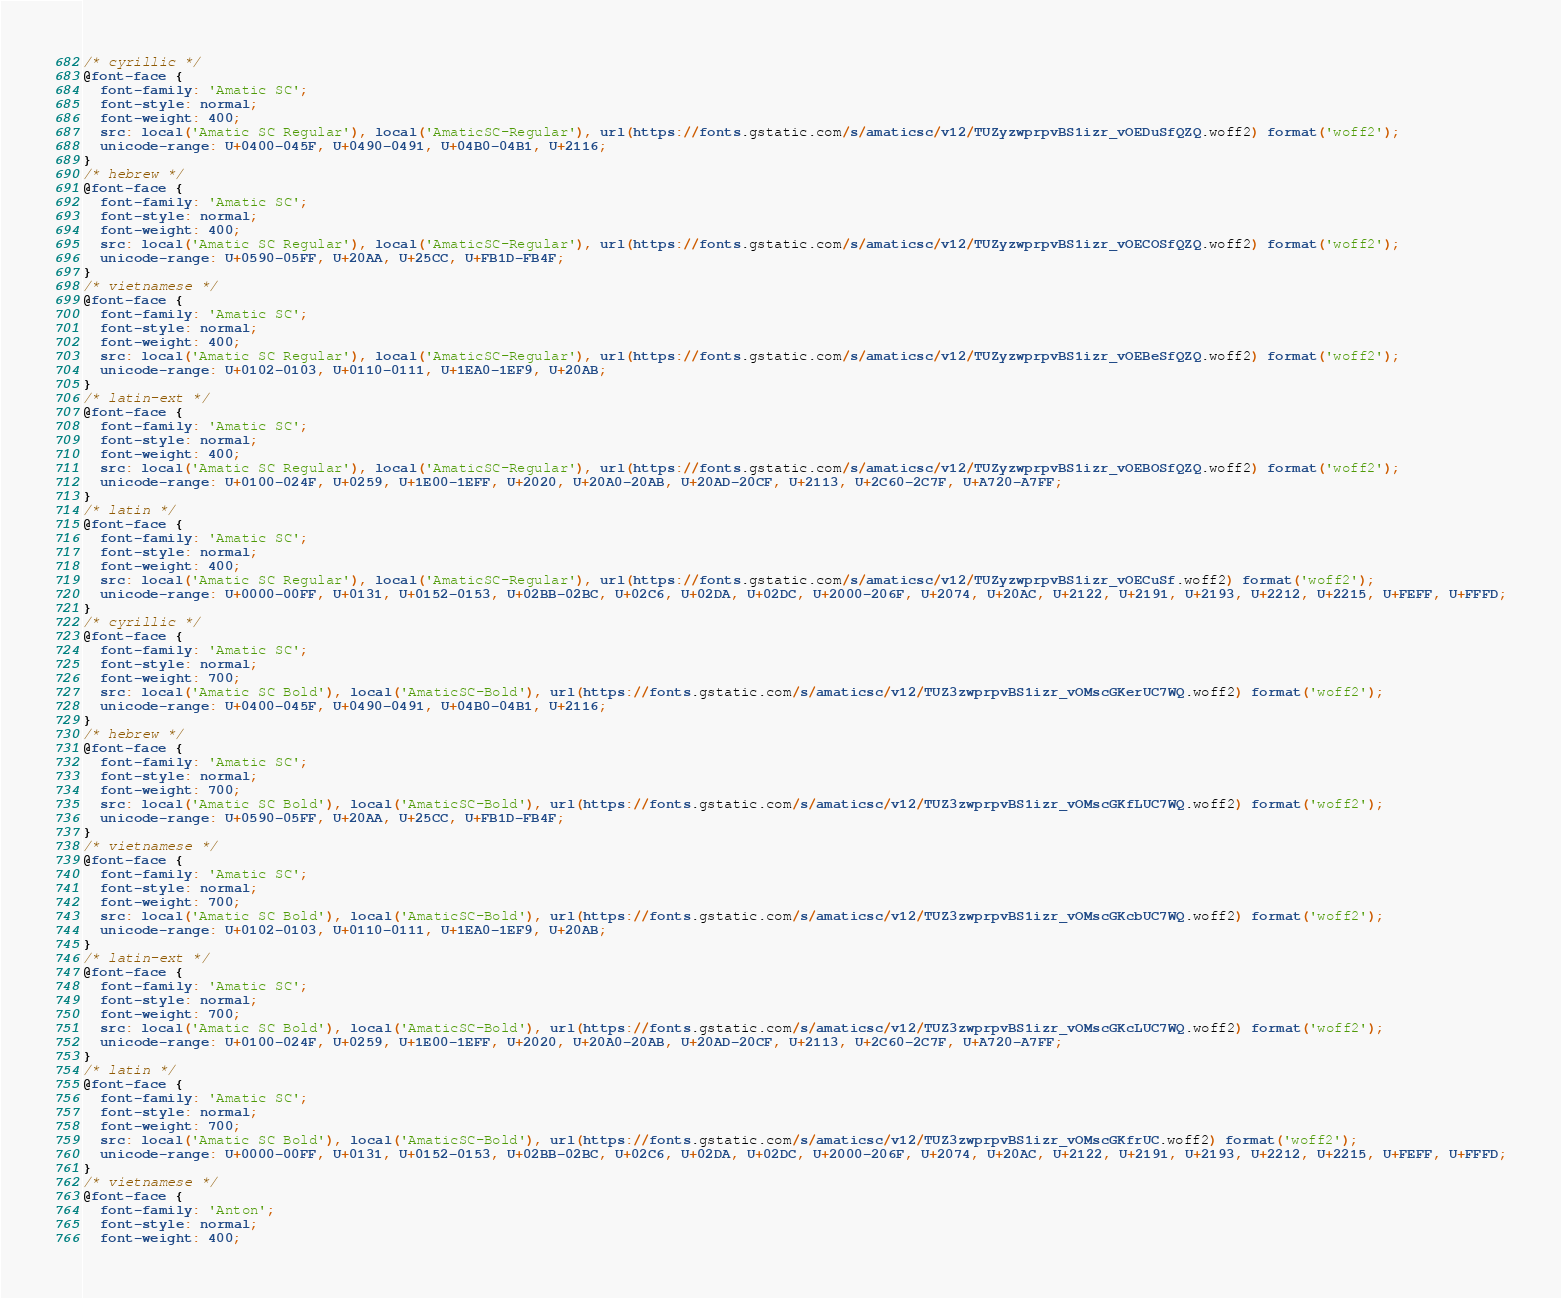Convert code to text. <code><loc_0><loc_0><loc_500><loc_500><_CSS_>/* cyrillic */
@font-face {
  font-family: 'Amatic SC';
  font-style: normal;
  font-weight: 400;
  src: local('Amatic SC Regular'), local('AmaticSC-Regular'), url(https://fonts.gstatic.com/s/amaticsc/v12/TUZyzwprpvBS1izr_vOEDuSfQZQ.woff2) format('woff2');
  unicode-range: U+0400-045F, U+0490-0491, U+04B0-04B1, U+2116;
}
/* hebrew */
@font-face {
  font-family: 'Amatic SC';
  font-style: normal;
  font-weight: 400;
  src: local('Amatic SC Regular'), local('AmaticSC-Regular'), url(https://fonts.gstatic.com/s/amaticsc/v12/TUZyzwprpvBS1izr_vOECOSfQZQ.woff2) format('woff2');
  unicode-range: U+0590-05FF, U+20AA, U+25CC, U+FB1D-FB4F;
}
/* vietnamese */
@font-face {
  font-family: 'Amatic SC';
  font-style: normal;
  font-weight: 400;
  src: local('Amatic SC Regular'), local('AmaticSC-Regular'), url(https://fonts.gstatic.com/s/amaticsc/v12/TUZyzwprpvBS1izr_vOEBeSfQZQ.woff2) format('woff2');
  unicode-range: U+0102-0103, U+0110-0111, U+1EA0-1EF9, U+20AB;
}
/* latin-ext */
@font-face {
  font-family: 'Amatic SC';
  font-style: normal;
  font-weight: 400;
  src: local('Amatic SC Regular'), local('AmaticSC-Regular'), url(https://fonts.gstatic.com/s/amaticsc/v12/TUZyzwprpvBS1izr_vOEBOSfQZQ.woff2) format('woff2');
  unicode-range: U+0100-024F, U+0259, U+1E00-1EFF, U+2020, U+20A0-20AB, U+20AD-20CF, U+2113, U+2C60-2C7F, U+A720-A7FF;
}
/* latin */
@font-face {
  font-family: 'Amatic SC';
  font-style: normal;
  font-weight: 400;
  src: local('Amatic SC Regular'), local('AmaticSC-Regular'), url(https://fonts.gstatic.com/s/amaticsc/v12/TUZyzwprpvBS1izr_vOECuSf.woff2) format('woff2');
  unicode-range: U+0000-00FF, U+0131, U+0152-0153, U+02BB-02BC, U+02C6, U+02DA, U+02DC, U+2000-206F, U+2074, U+20AC, U+2122, U+2191, U+2193, U+2212, U+2215, U+FEFF, U+FFFD;
}
/* cyrillic */
@font-face {
  font-family: 'Amatic SC';
  font-style: normal;
  font-weight: 700;
  src: local('Amatic SC Bold'), local('AmaticSC-Bold'), url(https://fonts.gstatic.com/s/amaticsc/v12/TUZ3zwprpvBS1izr_vOMscGKerUC7WQ.woff2) format('woff2');
  unicode-range: U+0400-045F, U+0490-0491, U+04B0-04B1, U+2116;
}
/* hebrew */
@font-face {
  font-family: 'Amatic SC';
  font-style: normal;
  font-weight: 700;
  src: local('Amatic SC Bold'), local('AmaticSC-Bold'), url(https://fonts.gstatic.com/s/amaticsc/v12/TUZ3zwprpvBS1izr_vOMscGKfLUC7WQ.woff2) format('woff2');
  unicode-range: U+0590-05FF, U+20AA, U+25CC, U+FB1D-FB4F;
}
/* vietnamese */
@font-face {
  font-family: 'Amatic SC';
  font-style: normal;
  font-weight: 700;
  src: local('Amatic SC Bold'), local('AmaticSC-Bold'), url(https://fonts.gstatic.com/s/amaticsc/v12/TUZ3zwprpvBS1izr_vOMscGKcbUC7WQ.woff2) format('woff2');
  unicode-range: U+0102-0103, U+0110-0111, U+1EA0-1EF9, U+20AB;
}
/* latin-ext */
@font-face {
  font-family: 'Amatic SC';
  font-style: normal;
  font-weight: 700;
  src: local('Amatic SC Bold'), local('AmaticSC-Bold'), url(https://fonts.gstatic.com/s/amaticsc/v12/TUZ3zwprpvBS1izr_vOMscGKcLUC7WQ.woff2) format('woff2');
  unicode-range: U+0100-024F, U+0259, U+1E00-1EFF, U+2020, U+20A0-20AB, U+20AD-20CF, U+2113, U+2C60-2C7F, U+A720-A7FF;
}
/* latin */
@font-face {
  font-family: 'Amatic SC';
  font-style: normal;
  font-weight: 700;
  src: local('Amatic SC Bold'), local('AmaticSC-Bold'), url(https://fonts.gstatic.com/s/amaticsc/v12/TUZ3zwprpvBS1izr_vOMscGKfrUC.woff2) format('woff2');
  unicode-range: U+0000-00FF, U+0131, U+0152-0153, U+02BB-02BC, U+02C6, U+02DA, U+02DC, U+2000-206F, U+2074, U+20AC, U+2122, U+2191, U+2193, U+2212, U+2215, U+FEFF, U+FFFD;
}
/* vietnamese */
@font-face {
  font-family: 'Anton';
  font-style: normal;
  font-weight: 400;</code> 